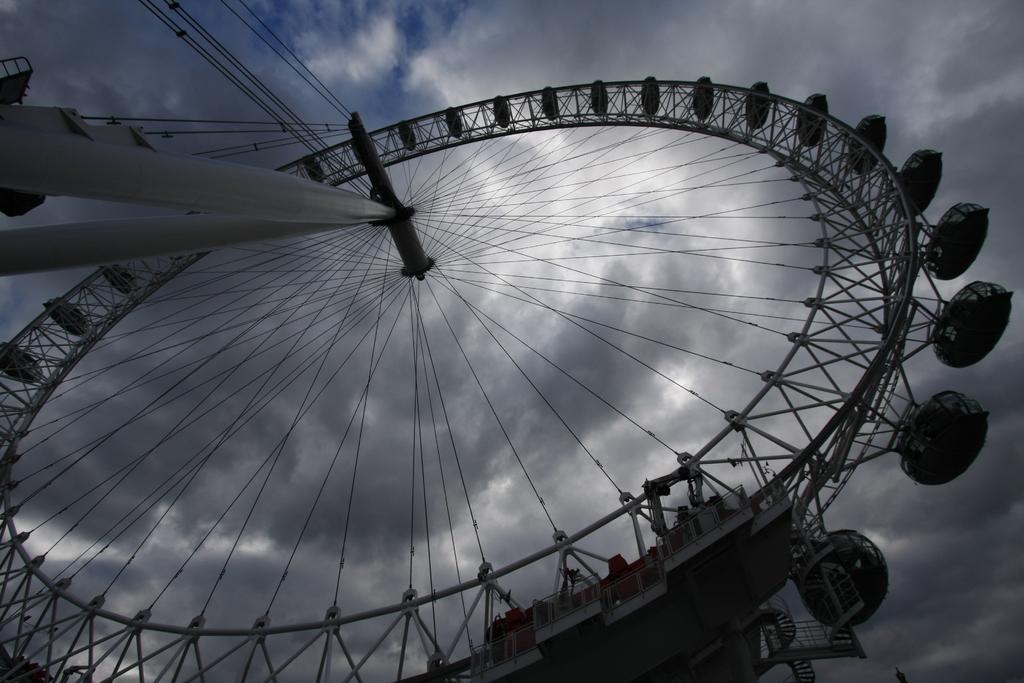Can you describe this image briefly? In this picture i can see a Columbus wheel and a cloudy sky. 